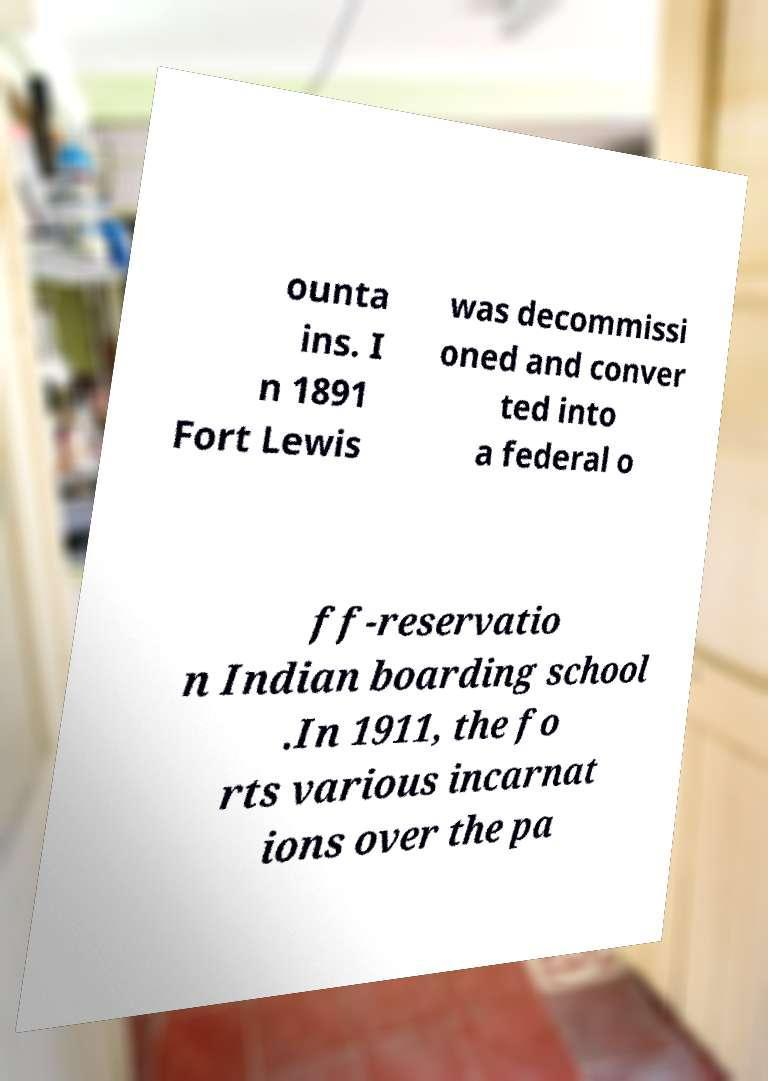I need the written content from this picture converted into text. Can you do that? ounta ins. I n 1891 Fort Lewis was decommissi oned and conver ted into a federal o ff-reservatio n Indian boarding school .In 1911, the fo rts various incarnat ions over the pa 